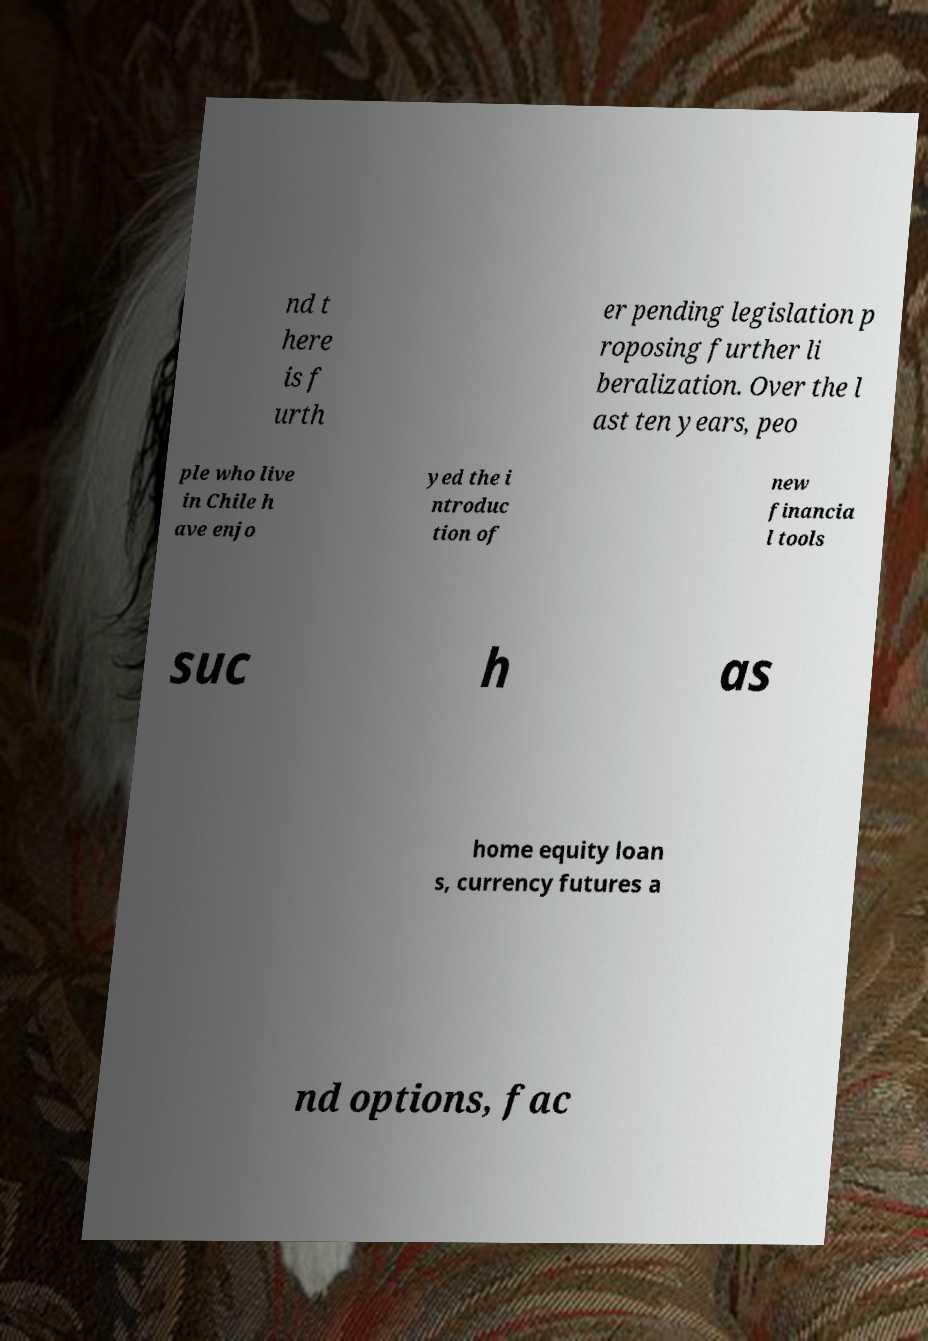Can you read and provide the text displayed in the image?This photo seems to have some interesting text. Can you extract and type it out for me? nd t here is f urth er pending legislation p roposing further li beralization. Over the l ast ten years, peo ple who live in Chile h ave enjo yed the i ntroduc tion of new financia l tools suc h as home equity loan s, currency futures a nd options, fac 